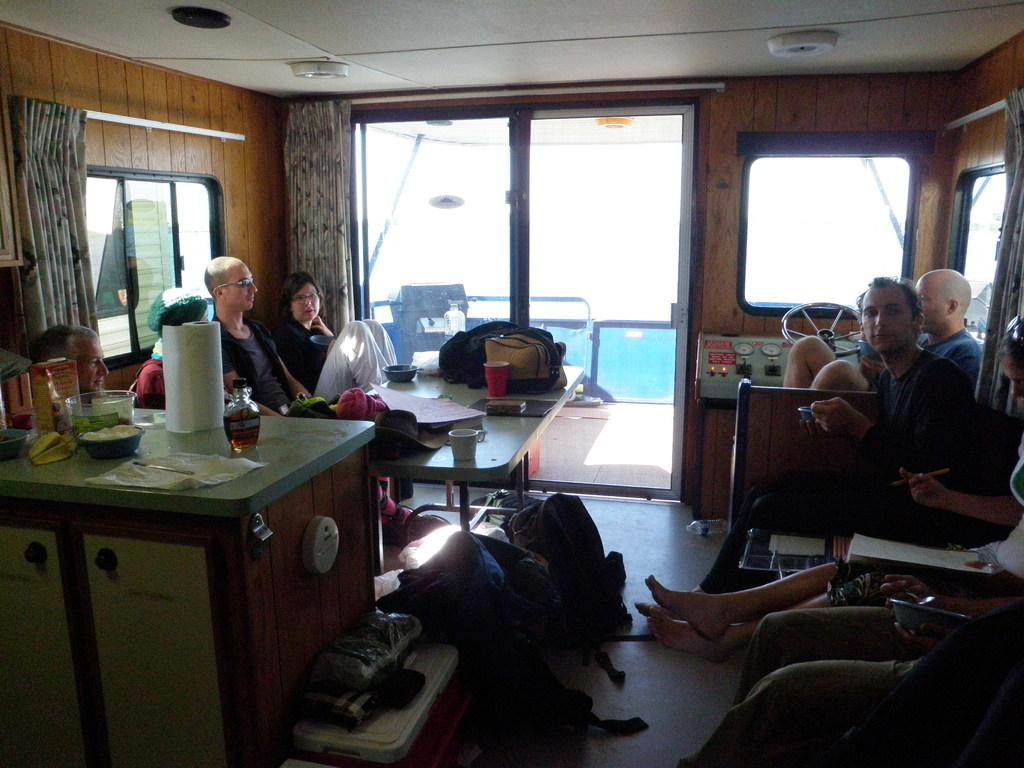What are the people in the image doing? The people in the image are seated on chairs. What objects can be seen on the table in the image? There is a bottle, a paper bundle, and bowls on the table. How many screws are visible on the table in the image? There are no screws visible on the table in the image. What type of eggs are being served in the bowls on the table? There are no eggs present in the image; the bowls contain unspecified items. 